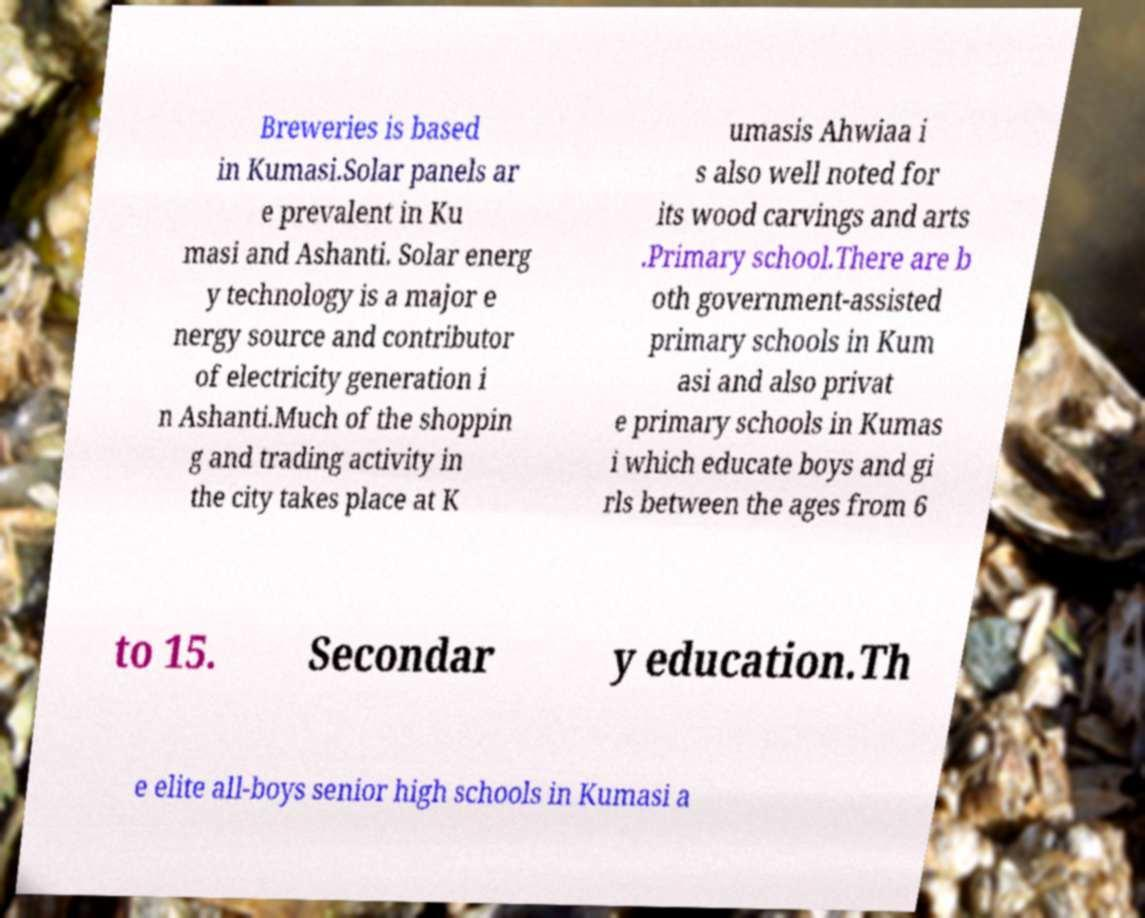Please read and relay the text visible in this image. What does it say? Breweries is based in Kumasi.Solar panels ar e prevalent in Ku masi and Ashanti. Solar energ y technology is a major e nergy source and contributor of electricity generation i n Ashanti.Much of the shoppin g and trading activity in the city takes place at K umasis Ahwiaa i s also well noted for its wood carvings and arts .Primary school.There are b oth government-assisted primary schools in Kum asi and also privat e primary schools in Kumas i which educate boys and gi rls between the ages from 6 to 15. Secondar y education.Th e elite all-boys senior high schools in Kumasi a 